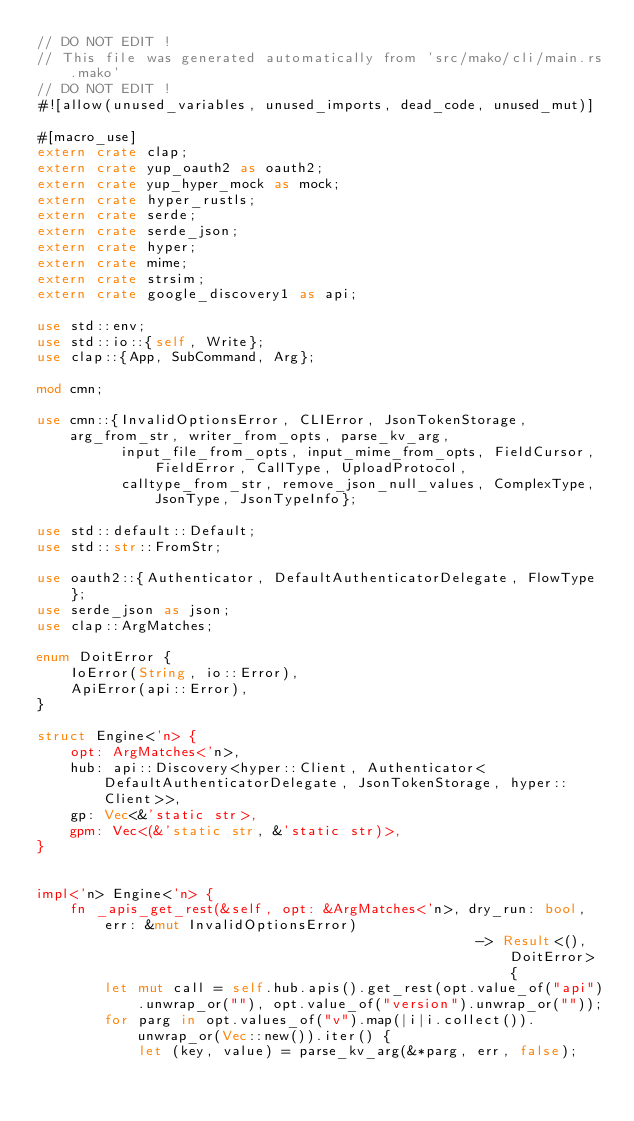Convert code to text. <code><loc_0><loc_0><loc_500><loc_500><_Rust_>// DO NOT EDIT !
// This file was generated automatically from 'src/mako/cli/main.rs.mako'
// DO NOT EDIT !
#![allow(unused_variables, unused_imports, dead_code, unused_mut)]

#[macro_use]
extern crate clap;
extern crate yup_oauth2 as oauth2;
extern crate yup_hyper_mock as mock;
extern crate hyper_rustls;
extern crate serde;
extern crate serde_json;
extern crate hyper;
extern crate mime;
extern crate strsim;
extern crate google_discovery1 as api;

use std::env;
use std::io::{self, Write};
use clap::{App, SubCommand, Arg};

mod cmn;

use cmn::{InvalidOptionsError, CLIError, JsonTokenStorage, arg_from_str, writer_from_opts, parse_kv_arg,
          input_file_from_opts, input_mime_from_opts, FieldCursor, FieldError, CallType, UploadProtocol,
          calltype_from_str, remove_json_null_values, ComplexType, JsonType, JsonTypeInfo};

use std::default::Default;
use std::str::FromStr;

use oauth2::{Authenticator, DefaultAuthenticatorDelegate, FlowType};
use serde_json as json;
use clap::ArgMatches;

enum DoitError {
    IoError(String, io::Error),
    ApiError(api::Error),
}

struct Engine<'n> {
    opt: ArgMatches<'n>,
    hub: api::Discovery<hyper::Client, Authenticator<DefaultAuthenticatorDelegate, JsonTokenStorage, hyper::Client>>,
    gp: Vec<&'static str>,
    gpm: Vec<(&'static str, &'static str)>,
}


impl<'n> Engine<'n> {
    fn _apis_get_rest(&self, opt: &ArgMatches<'n>, dry_run: bool, err: &mut InvalidOptionsError)
                                                    -> Result<(), DoitError> {
        let mut call = self.hub.apis().get_rest(opt.value_of("api").unwrap_or(""), opt.value_of("version").unwrap_or(""));
        for parg in opt.values_of("v").map(|i|i.collect()).unwrap_or(Vec::new()).iter() {
            let (key, value) = parse_kv_arg(&*parg, err, false);</code> 